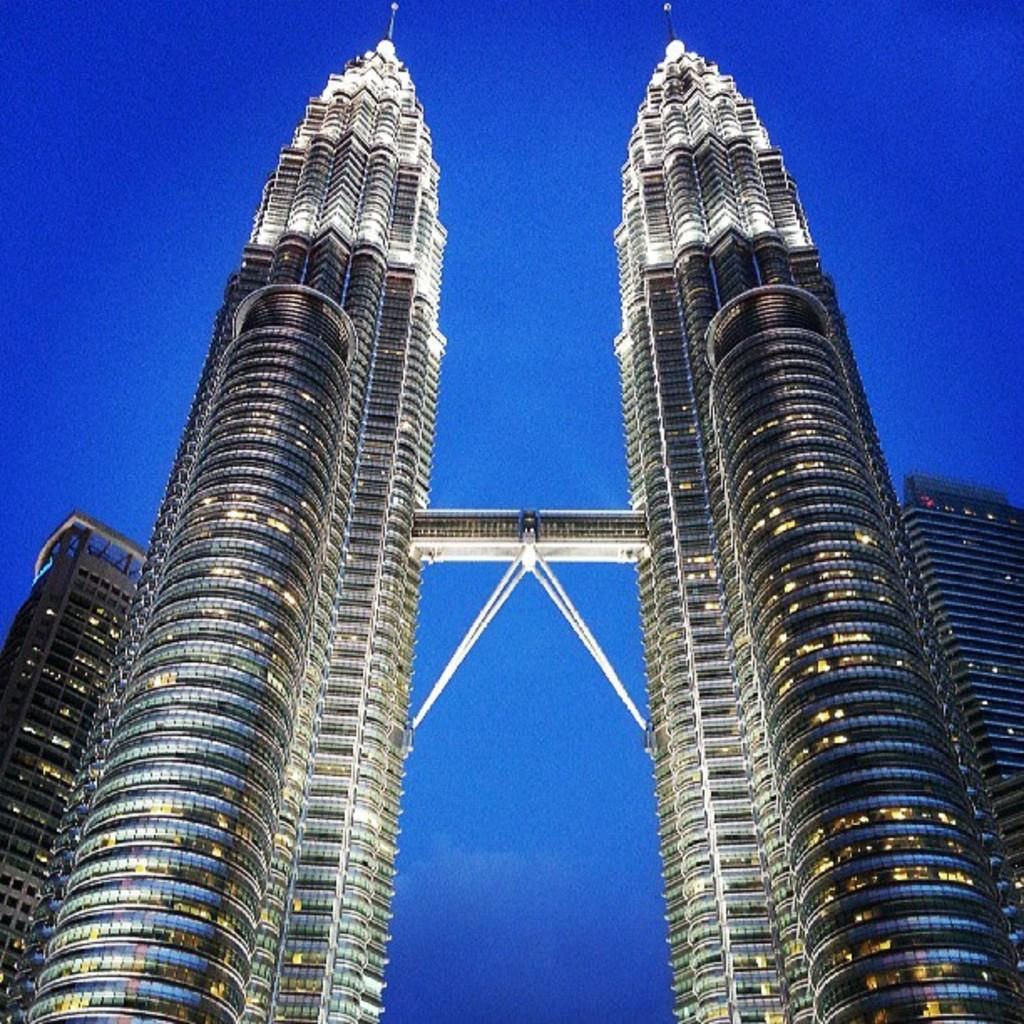What type of structures can be seen in the image? There are buildings in the image. What can be seen illuminating the scene in the image? There are lights visible in the image. How are the buildings connected in the image? There is a bridge between two buildings in the image. What part of the natural environment is visible in the image? The sky is visible in the image. How many rooms are visible in the image? There is no reference to rooms in the image, as it features buildings, lights, a bridge, and the sky. 